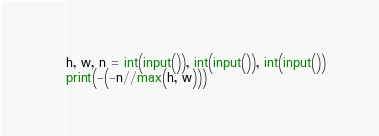Convert code to text. <code><loc_0><loc_0><loc_500><loc_500><_Python_>h, w, n = int(input()), int(input()), int(input())
print(-(-n//max(h, w)))
</code> 